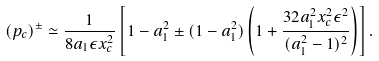Convert formula to latex. <formula><loc_0><loc_0><loc_500><loc_500>( p _ { c } ) ^ { \pm } \simeq \frac { 1 } { 8 a _ { 1 } \epsilon x _ { c } ^ { 2 } } \left [ 1 - a _ { 1 } ^ { 2 } \pm ( 1 - a _ { 1 } ^ { 2 } ) \left ( 1 + \frac { 3 2 a _ { 1 } ^ { 2 } x _ { c } ^ { 2 } \epsilon ^ { 2 } } { ( a _ { 1 } ^ { 2 } - 1 ) ^ { 2 } } \right ) \right ] .</formula> 